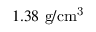Convert formula to latex. <formula><loc_0><loc_0><loc_500><loc_500>1 . 3 8 g / c m ^ { 3 }</formula> 